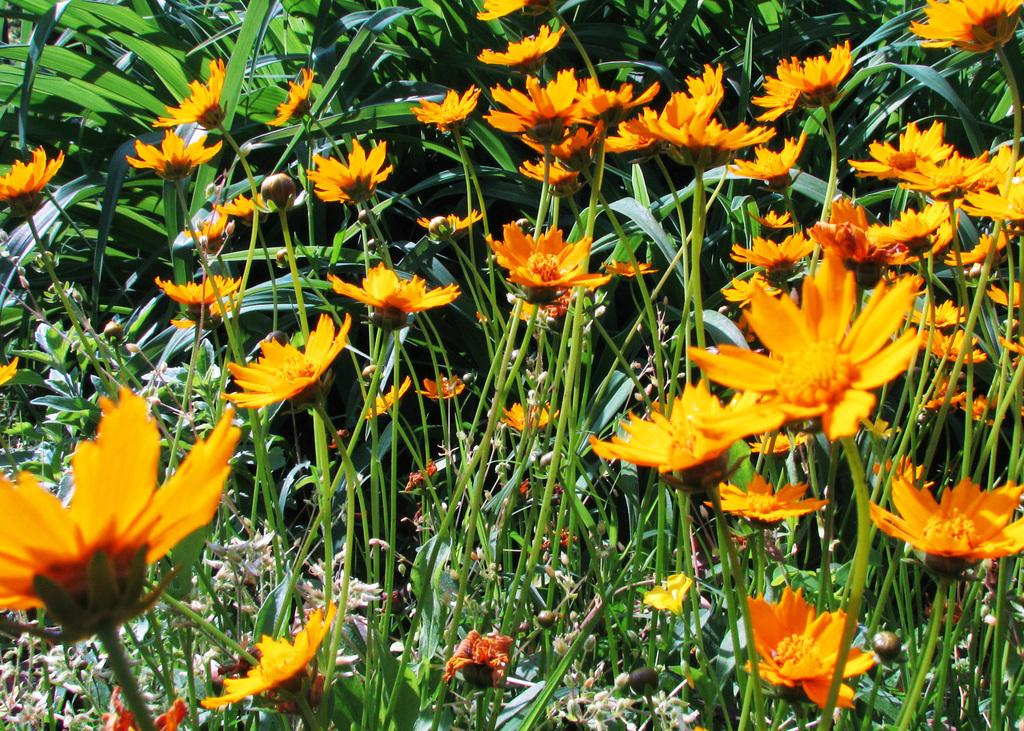What type of living organisms can be seen in the image? Plants can be seen in the image. What specific features can be observed on the plants? The plants have flowers and green leaves. What type of fabric is used to make the silk flowers in the image? There are no silk flowers present in the image; the plants have real flowers. 